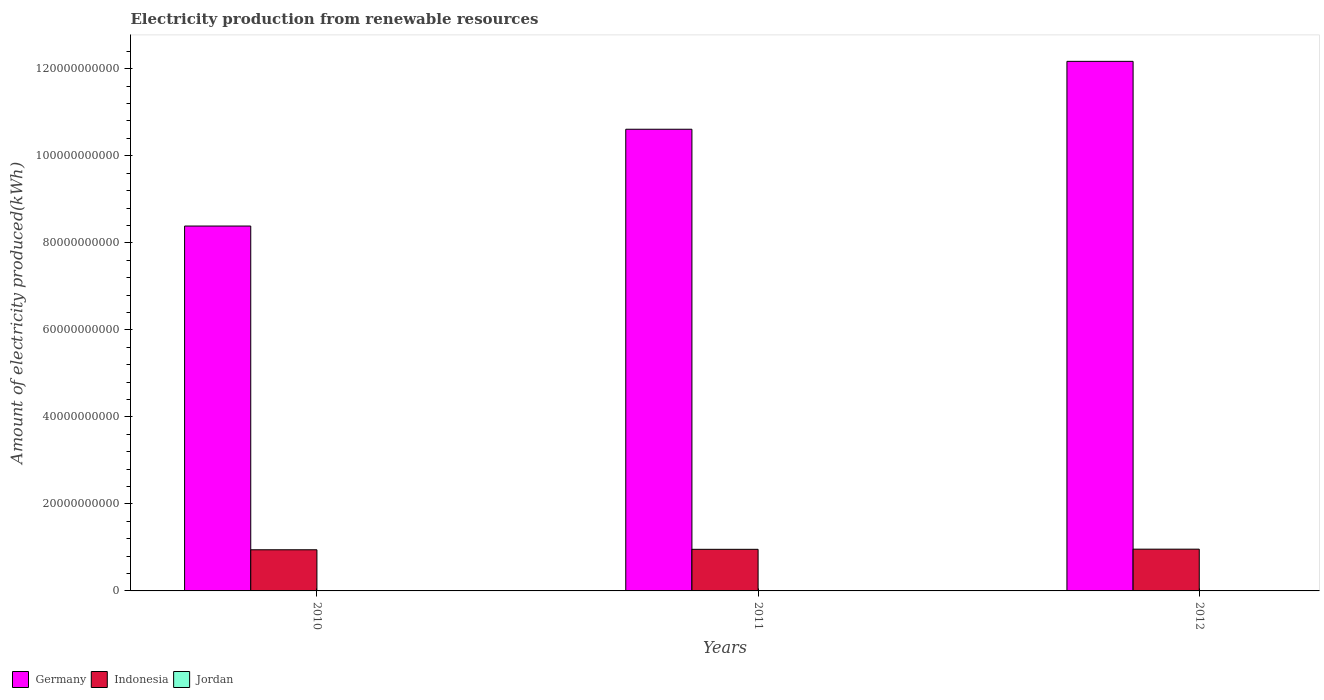How many groups of bars are there?
Keep it short and to the point. 3. Are the number of bars per tick equal to the number of legend labels?
Your answer should be very brief. Yes. How many bars are there on the 3rd tick from the left?
Provide a succinct answer. 3. In how many cases, is the number of bars for a given year not equal to the number of legend labels?
Provide a short and direct response. 0. What is the amount of electricity produced in Indonesia in 2010?
Provide a short and direct response. 9.46e+09. Across all years, what is the maximum amount of electricity produced in Indonesia?
Your response must be concise. 9.60e+09. Across all years, what is the minimum amount of electricity produced in Jordan?
Ensure brevity in your answer.  9.00e+06. In which year was the amount of electricity produced in Jordan minimum?
Your response must be concise. 2012. What is the total amount of electricity produced in Germany in the graph?
Your answer should be compact. 3.12e+11. What is the difference between the amount of electricity produced in Indonesia in 2011 and that in 2012?
Give a very brief answer. -3.60e+07. What is the difference between the amount of electricity produced in Germany in 2010 and the amount of electricity produced in Jordan in 2012?
Keep it short and to the point. 8.38e+1. What is the average amount of electricity produced in Germany per year?
Provide a succinct answer. 1.04e+11. In the year 2012, what is the difference between the amount of electricity produced in Indonesia and amount of electricity produced in Jordan?
Ensure brevity in your answer.  9.59e+09. In how many years, is the amount of electricity produced in Germany greater than 64000000000 kWh?
Your answer should be compact. 3. What is the ratio of the amount of electricity produced in Jordan in 2011 to that in 2012?
Offer a very short reply. 1.22. What is the difference between the highest and the lowest amount of electricity produced in Jordan?
Ensure brevity in your answer.  3.00e+06. Is the sum of the amount of electricity produced in Jordan in 2011 and 2012 greater than the maximum amount of electricity produced in Germany across all years?
Provide a succinct answer. No. What does the 3rd bar from the left in 2011 represents?
Your answer should be very brief. Jordan. What does the 2nd bar from the right in 2012 represents?
Your answer should be compact. Indonesia. How many bars are there?
Provide a short and direct response. 9. How many years are there in the graph?
Your answer should be compact. 3. What is the difference between two consecutive major ticks on the Y-axis?
Offer a very short reply. 2.00e+1. Does the graph contain grids?
Make the answer very short. No. What is the title of the graph?
Provide a short and direct response. Electricity production from renewable resources. Does "Morocco" appear as one of the legend labels in the graph?
Provide a succinct answer. No. What is the label or title of the X-axis?
Give a very brief answer. Years. What is the label or title of the Y-axis?
Your answer should be compact. Amount of electricity produced(kWh). What is the Amount of electricity produced(kWh) in Germany in 2010?
Offer a terse response. 8.39e+1. What is the Amount of electricity produced(kWh) in Indonesia in 2010?
Your answer should be compact. 9.46e+09. What is the Amount of electricity produced(kWh) of Jordan in 2010?
Make the answer very short. 1.20e+07. What is the Amount of electricity produced(kWh) in Germany in 2011?
Give a very brief answer. 1.06e+11. What is the Amount of electricity produced(kWh) of Indonesia in 2011?
Keep it short and to the point. 9.56e+09. What is the Amount of electricity produced(kWh) of Jordan in 2011?
Provide a short and direct response. 1.10e+07. What is the Amount of electricity produced(kWh) in Germany in 2012?
Provide a succinct answer. 1.22e+11. What is the Amount of electricity produced(kWh) of Indonesia in 2012?
Offer a terse response. 9.60e+09. What is the Amount of electricity produced(kWh) in Jordan in 2012?
Your response must be concise. 9.00e+06. Across all years, what is the maximum Amount of electricity produced(kWh) in Germany?
Give a very brief answer. 1.22e+11. Across all years, what is the maximum Amount of electricity produced(kWh) in Indonesia?
Your response must be concise. 9.60e+09. Across all years, what is the minimum Amount of electricity produced(kWh) in Germany?
Your answer should be compact. 8.39e+1. Across all years, what is the minimum Amount of electricity produced(kWh) in Indonesia?
Keep it short and to the point. 9.46e+09. Across all years, what is the minimum Amount of electricity produced(kWh) in Jordan?
Make the answer very short. 9.00e+06. What is the total Amount of electricity produced(kWh) of Germany in the graph?
Give a very brief answer. 3.12e+11. What is the total Amount of electricity produced(kWh) in Indonesia in the graph?
Make the answer very short. 2.86e+1. What is the total Amount of electricity produced(kWh) in Jordan in the graph?
Provide a short and direct response. 3.20e+07. What is the difference between the Amount of electricity produced(kWh) in Germany in 2010 and that in 2011?
Your answer should be very brief. -2.22e+1. What is the difference between the Amount of electricity produced(kWh) of Indonesia in 2010 and that in 2011?
Provide a short and direct response. -1.04e+08. What is the difference between the Amount of electricity produced(kWh) in Germany in 2010 and that in 2012?
Provide a short and direct response. -3.78e+1. What is the difference between the Amount of electricity produced(kWh) in Indonesia in 2010 and that in 2012?
Provide a succinct answer. -1.40e+08. What is the difference between the Amount of electricity produced(kWh) in Germany in 2011 and that in 2012?
Keep it short and to the point. -1.56e+1. What is the difference between the Amount of electricity produced(kWh) in Indonesia in 2011 and that in 2012?
Your answer should be very brief. -3.60e+07. What is the difference between the Amount of electricity produced(kWh) of Jordan in 2011 and that in 2012?
Provide a succinct answer. 2.00e+06. What is the difference between the Amount of electricity produced(kWh) of Germany in 2010 and the Amount of electricity produced(kWh) of Indonesia in 2011?
Ensure brevity in your answer.  7.43e+1. What is the difference between the Amount of electricity produced(kWh) in Germany in 2010 and the Amount of electricity produced(kWh) in Jordan in 2011?
Your answer should be compact. 8.38e+1. What is the difference between the Amount of electricity produced(kWh) of Indonesia in 2010 and the Amount of electricity produced(kWh) of Jordan in 2011?
Provide a succinct answer. 9.44e+09. What is the difference between the Amount of electricity produced(kWh) in Germany in 2010 and the Amount of electricity produced(kWh) in Indonesia in 2012?
Your answer should be very brief. 7.43e+1. What is the difference between the Amount of electricity produced(kWh) in Germany in 2010 and the Amount of electricity produced(kWh) in Jordan in 2012?
Make the answer very short. 8.38e+1. What is the difference between the Amount of electricity produced(kWh) of Indonesia in 2010 and the Amount of electricity produced(kWh) of Jordan in 2012?
Give a very brief answer. 9.45e+09. What is the difference between the Amount of electricity produced(kWh) of Germany in 2011 and the Amount of electricity produced(kWh) of Indonesia in 2012?
Keep it short and to the point. 9.65e+1. What is the difference between the Amount of electricity produced(kWh) of Germany in 2011 and the Amount of electricity produced(kWh) of Jordan in 2012?
Offer a terse response. 1.06e+11. What is the difference between the Amount of electricity produced(kWh) of Indonesia in 2011 and the Amount of electricity produced(kWh) of Jordan in 2012?
Keep it short and to the point. 9.55e+09. What is the average Amount of electricity produced(kWh) of Germany per year?
Give a very brief answer. 1.04e+11. What is the average Amount of electricity produced(kWh) in Indonesia per year?
Keep it short and to the point. 9.54e+09. What is the average Amount of electricity produced(kWh) of Jordan per year?
Provide a succinct answer. 1.07e+07. In the year 2010, what is the difference between the Amount of electricity produced(kWh) in Germany and Amount of electricity produced(kWh) in Indonesia?
Provide a short and direct response. 7.44e+1. In the year 2010, what is the difference between the Amount of electricity produced(kWh) of Germany and Amount of electricity produced(kWh) of Jordan?
Provide a succinct answer. 8.38e+1. In the year 2010, what is the difference between the Amount of electricity produced(kWh) in Indonesia and Amount of electricity produced(kWh) in Jordan?
Offer a terse response. 9.44e+09. In the year 2011, what is the difference between the Amount of electricity produced(kWh) in Germany and Amount of electricity produced(kWh) in Indonesia?
Ensure brevity in your answer.  9.65e+1. In the year 2011, what is the difference between the Amount of electricity produced(kWh) in Germany and Amount of electricity produced(kWh) in Jordan?
Provide a short and direct response. 1.06e+11. In the year 2011, what is the difference between the Amount of electricity produced(kWh) in Indonesia and Amount of electricity produced(kWh) in Jordan?
Your answer should be compact. 9.55e+09. In the year 2012, what is the difference between the Amount of electricity produced(kWh) of Germany and Amount of electricity produced(kWh) of Indonesia?
Offer a terse response. 1.12e+11. In the year 2012, what is the difference between the Amount of electricity produced(kWh) in Germany and Amount of electricity produced(kWh) in Jordan?
Provide a succinct answer. 1.22e+11. In the year 2012, what is the difference between the Amount of electricity produced(kWh) of Indonesia and Amount of electricity produced(kWh) of Jordan?
Give a very brief answer. 9.59e+09. What is the ratio of the Amount of electricity produced(kWh) in Germany in 2010 to that in 2011?
Make the answer very short. 0.79. What is the ratio of the Amount of electricity produced(kWh) of Germany in 2010 to that in 2012?
Ensure brevity in your answer.  0.69. What is the ratio of the Amount of electricity produced(kWh) of Indonesia in 2010 to that in 2012?
Provide a succinct answer. 0.99. What is the ratio of the Amount of electricity produced(kWh) of Jordan in 2010 to that in 2012?
Keep it short and to the point. 1.33. What is the ratio of the Amount of electricity produced(kWh) of Germany in 2011 to that in 2012?
Your response must be concise. 0.87. What is the ratio of the Amount of electricity produced(kWh) of Indonesia in 2011 to that in 2012?
Keep it short and to the point. 1. What is the ratio of the Amount of electricity produced(kWh) of Jordan in 2011 to that in 2012?
Provide a short and direct response. 1.22. What is the difference between the highest and the second highest Amount of electricity produced(kWh) in Germany?
Your response must be concise. 1.56e+1. What is the difference between the highest and the second highest Amount of electricity produced(kWh) in Indonesia?
Keep it short and to the point. 3.60e+07. What is the difference between the highest and the lowest Amount of electricity produced(kWh) in Germany?
Keep it short and to the point. 3.78e+1. What is the difference between the highest and the lowest Amount of electricity produced(kWh) of Indonesia?
Provide a succinct answer. 1.40e+08. What is the difference between the highest and the lowest Amount of electricity produced(kWh) in Jordan?
Offer a terse response. 3.00e+06. 